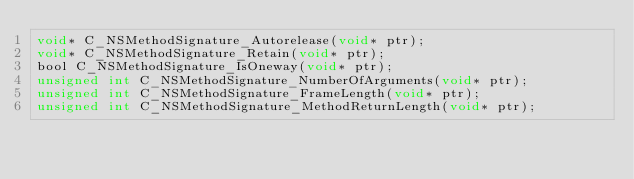Convert code to text. <code><loc_0><loc_0><loc_500><loc_500><_C_>void* C_NSMethodSignature_Autorelease(void* ptr);
void* C_NSMethodSignature_Retain(void* ptr);
bool C_NSMethodSignature_IsOneway(void* ptr);
unsigned int C_NSMethodSignature_NumberOfArguments(void* ptr);
unsigned int C_NSMethodSignature_FrameLength(void* ptr);
unsigned int C_NSMethodSignature_MethodReturnLength(void* ptr);
</code> 